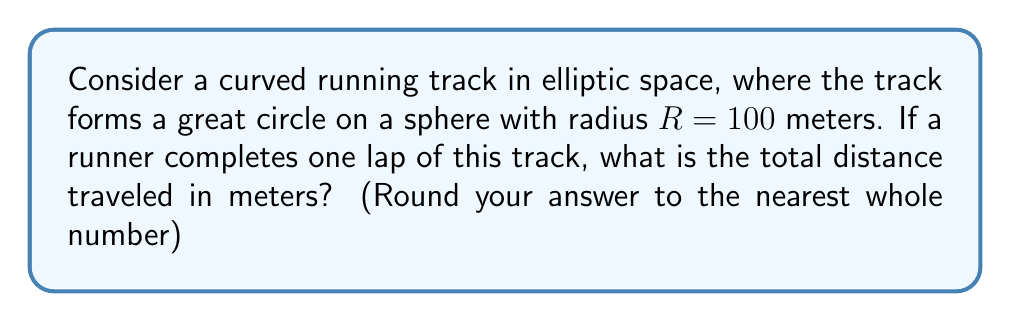Help me with this question. Let's approach this step-by-step:

1) In elliptic geometry, straight lines are represented by great circles on a sphere.

2) The length of a great circle on a sphere is equal to the circumference of that sphere.

3) The formula for the circumference of a sphere is:

   $$C = 2\pi R$$

   Where:
   $C$ is the circumference
   $R$ is the radius of the sphere

4) Given:
   $R = 100$ meters

5) Let's substitute this into our formula:

   $$C = 2\pi (100)$$

6) Simplify:
   $$C = 200\pi$$

7) Calculate:
   $$C \approx 628.32 \text{ meters}$$

8) Rounding to the nearest whole number:
   $$C \approx 628 \text{ meters}$$

This result shows how non-Euclidean geometry can affect measurements in sports. In a flat (Euclidean) space, a circular track with the same radius would have a longer circumference of $2\pi R = 200\pi \approx 628.32$ meters. The curvature of elliptic space effectively "shrinks" the distance, which could impact race times and strategies in this hypothetical curved space.
Answer: 628 meters 